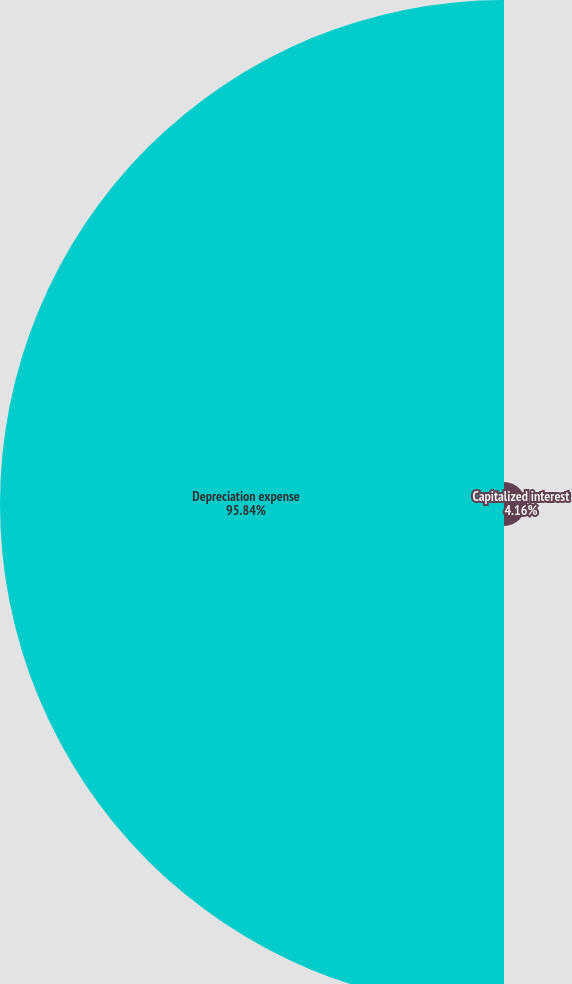<chart> <loc_0><loc_0><loc_500><loc_500><pie_chart><fcel>Capitalized interest<fcel>Depreciation expense<nl><fcel>4.16%<fcel>95.84%<nl></chart> 